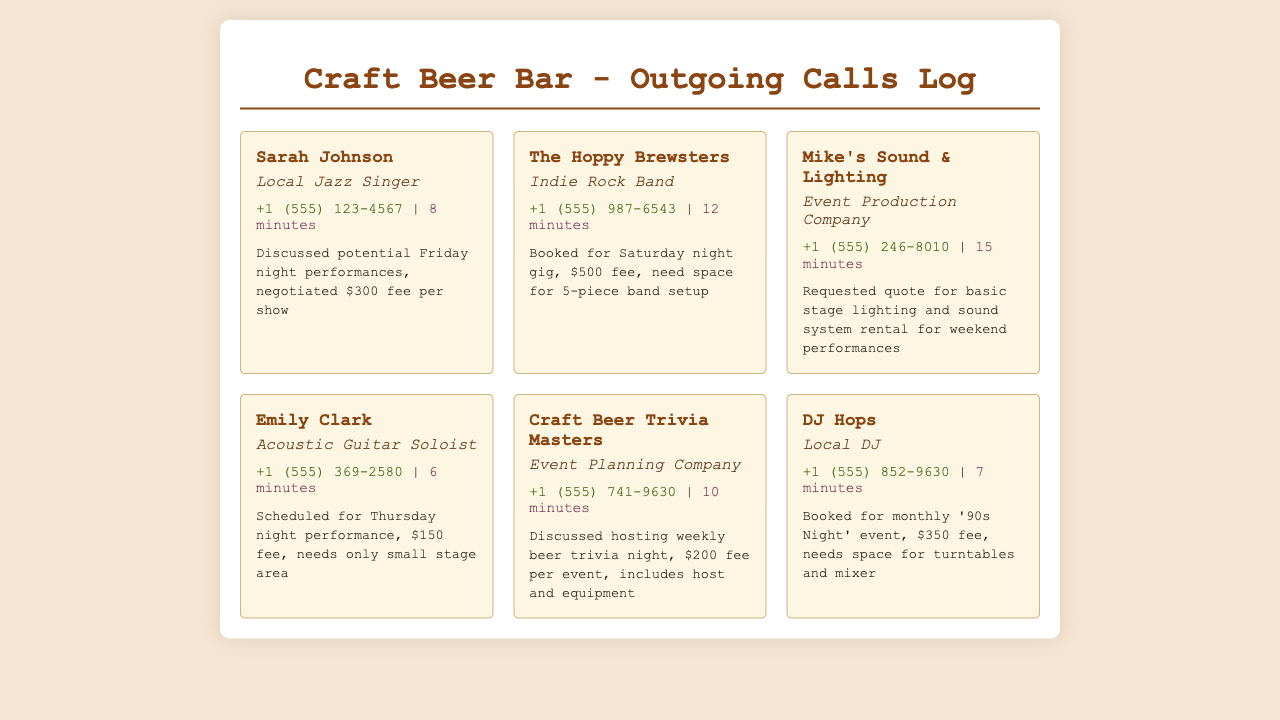what is the name of the acoustic guitar soloist? The document lists Emily Clark as the acoustic guitar soloist.
Answer: Emily Clark how long was the call with The Hoppy Brewsters? The call duration for The Hoppy Brewsters is mentioned as 12 minutes.
Answer: 12 minutes what is the fee for the trivia night hosted by Craft Beer Trivia Masters? The document states that the fee per event for the trivia night is $200.
Answer: $200 who is booked for the Saturday night gig? The Hoppy Brewsters are booked for the Saturday night gig.
Answer: The Hoppy Brewsters how many minutes did the call with Mike's Sound & Lighting last? The duration of the call with Mike's Sound & Lighting is 15 minutes.
Answer: 15 minutes what type of music does DJ Hops play? The document specifies DJ Hops as a local DJ.
Answer: Local DJ which performer only needs a small stage area? Emily Clark is the performer who needs only a small stage area.
Answer: Emily Clark what is the contact type of Sarah Johnson? Sarah Johnson is identified as a local jazz singer in the document.
Answer: Local Jazz Singer 